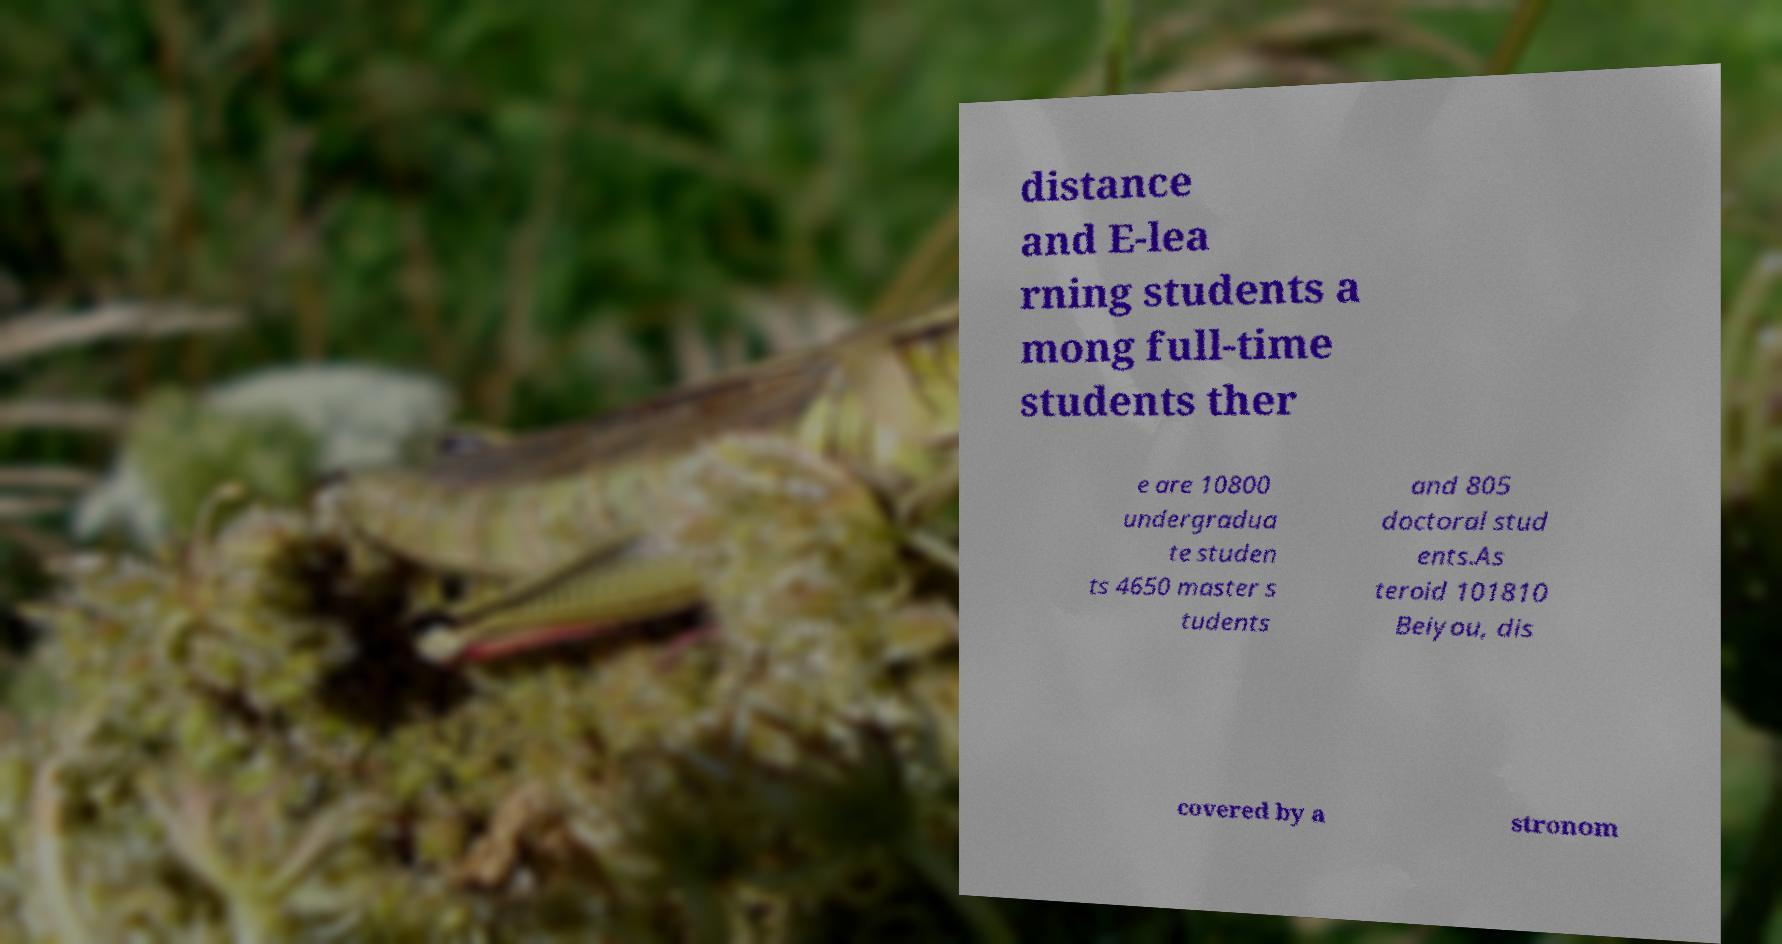Please read and relay the text visible in this image. What does it say? distance and E-lea rning students a mong full-time students ther e are 10800 undergradua te studen ts 4650 master s tudents and 805 doctoral stud ents.As teroid 101810 Beiyou, dis covered by a stronom 